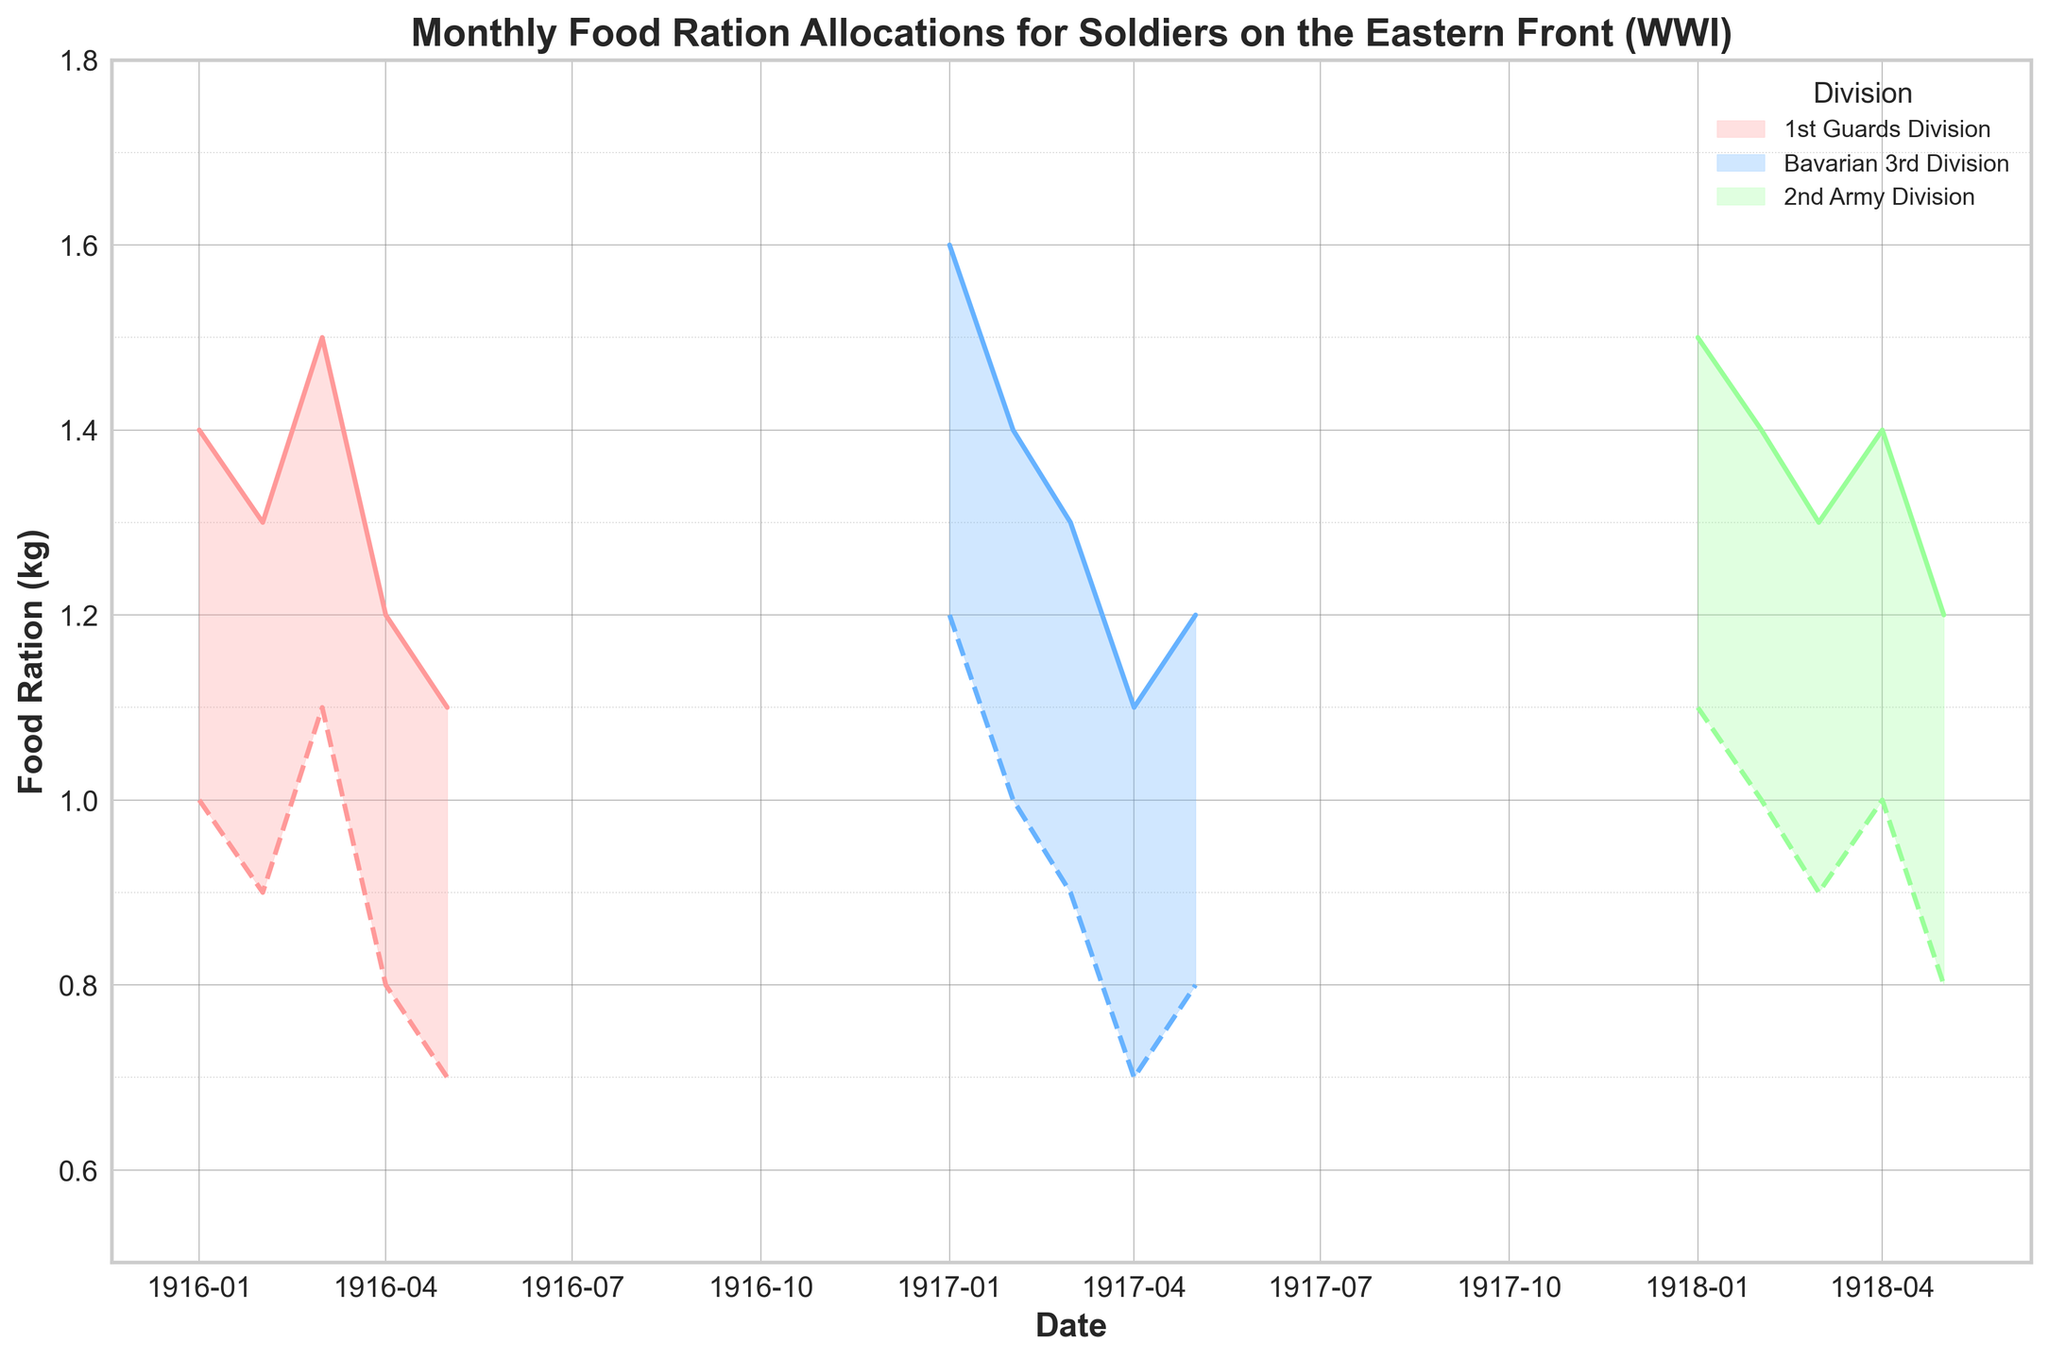What is the range of food ration allocations for the 1st Guards Division in January 1916? Observing the plot for the 1st Guards Division in January 1916, we see the shaded area indicating the range. The minimum ration is 1.0 kg and the maximum ration is 1.4 kg.
Answer: 1.0 kg to 1.4 kg Which division had the highest maximum ration in January, and what was the amount? Look at the peaks of the solid lines in January for each division. The Bavarian 3rd Division in January 1917 has the highest maximum ration at 1.6 kg.
Answer: Bavarian 3rd Division, 1.6 kg In which month and year did the 2nd Army Division experience its lowest minimum ration, and what was the value? Trace the dashed lines of the 2nd Army Division to find the lowest minimum ration. This occurs in May 1918 with a value of 0.8 kg.
Answer: May 1918, 0.8 kg How did the food ration range for the Bavarian 3rd Division change from January to May 1917? Compare the range (from minimum to maximum rations) of the Bavarian 3rd Division from January to May 1917. The range in January is 1.2 - 1.6 kg, decreasing to 0.8 - 1.2 kg in May.
Answer: Decreased from 1.2-1.6 kg to 0.8-1.2 kg Which division showed the most stability in their food rationing over the observed period, and how can this be inferred? By examining the plot, the 2nd Army Division shows the most stability, as its minimum and maximum rations do not vary as widely across the months compared to the other divisions.
Answer: 2nd Army Division During which month and year could we observe the smallest gap between the minimum and maximum rations for the 1st Guards Division, and what was the gap? Analyze the 1st Guards Division's range and find the month with the smallest gap. In May 1916, the gap between 0.7 kg and 1.1 kg is the smallest, being 0.4 kg.
Answer: May 1916, 0.4 kg In April of which year did a division experience the higher maximum ration compared between Bavarian 3rd Division and 2nd Army Division? Compare the solid lines for April of the Bavarian 3rd Division and the 2nd Army Division. The Bavarian 3rd Division in April 1917 has a higher maximum ration of 1.1 kg compared to 1.4 kg of the 2nd Army Division in April 1918.
Answer: April 1918, 2nd Army Division What is the difference in the minimum rations between the 1st Guards Division in January 1916 and the Bavarian 3rd Division in January 1917? For January 1916, the 1st Guards Division has a minimum ration of 1.0 kg. For January 1917, the Bavarian 3rd Division has a minimum ration of 1.2 kg. The difference is 1.2 kg - 1.0 kg = 0.2 kg.
Answer: 0.2 kg How does the food ration allocation trend change for the divisions from the start to the end of the recorded period? Examine the overall trend lines for each division from their starting month to their ending month. The 1st Guards Division shows a decreasing trend, the Bavarian 3rd Division also decreases slightly, while the 2nd Army Division shows relatively stable trends.
Answer: 1st Guards: decreasing, Bavarian 3rd: decreasing, 2nd Army: stable Compare the average maximum ration for the Bavarian 3rd Division over the five months in 1917. Calculate the average of the maximum rations for each month of the Bavarian 3rd Division in 1917: (1.6 + 1.4 + 1.3 + 1.1 + 1.2) / 5 = 6.6 / 5 = 1.32 kg.
Answer: 1.32 kg 